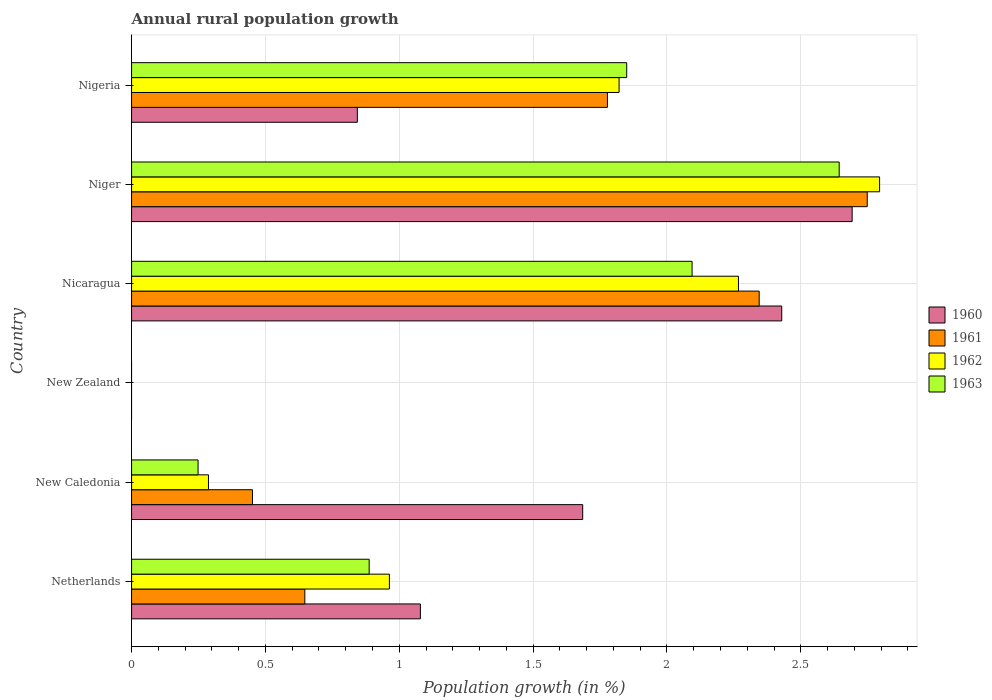How many different coloured bars are there?
Give a very brief answer. 4. What is the label of the 4th group of bars from the top?
Keep it short and to the point. New Zealand. What is the percentage of rural population growth in 1963 in Nigeria?
Ensure brevity in your answer.  1.85. Across all countries, what is the maximum percentage of rural population growth in 1963?
Your answer should be compact. 2.64. In which country was the percentage of rural population growth in 1961 maximum?
Offer a very short reply. Niger. What is the total percentage of rural population growth in 1961 in the graph?
Ensure brevity in your answer.  7.97. What is the difference between the percentage of rural population growth in 1962 in Nicaragua and that in Niger?
Offer a terse response. -0.53. What is the difference between the percentage of rural population growth in 1960 in Nigeria and the percentage of rural population growth in 1962 in Netherlands?
Your answer should be compact. -0.12. What is the average percentage of rural population growth in 1962 per country?
Provide a succinct answer. 1.36. What is the difference between the percentage of rural population growth in 1961 and percentage of rural population growth in 1962 in Nicaragua?
Your answer should be compact. 0.08. In how many countries, is the percentage of rural population growth in 1961 greater than 2.2 %?
Make the answer very short. 2. What is the ratio of the percentage of rural population growth in 1963 in New Caledonia to that in Nicaragua?
Keep it short and to the point. 0.12. Is the percentage of rural population growth in 1962 in Netherlands less than that in Nicaragua?
Make the answer very short. Yes. Is the difference between the percentage of rural population growth in 1961 in New Caledonia and Niger greater than the difference between the percentage of rural population growth in 1962 in New Caledonia and Niger?
Your response must be concise. Yes. What is the difference between the highest and the second highest percentage of rural population growth in 1963?
Make the answer very short. 0.55. What is the difference between the highest and the lowest percentage of rural population growth in 1960?
Provide a short and direct response. 2.69. Is it the case that in every country, the sum of the percentage of rural population growth in 1960 and percentage of rural population growth in 1962 is greater than the percentage of rural population growth in 1961?
Offer a terse response. No. Are all the bars in the graph horizontal?
Offer a very short reply. Yes. How many countries are there in the graph?
Make the answer very short. 6. Are the values on the major ticks of X-axis written in scientific E-notation?
Offer a very short reply. No. Where does the legend appear in the graph?
Ensure brevity in your answer.  Center right. What is the title of the graph?
Give a very brief answer. Annual rural population growth. What is the label or title of the X-axis?
Your answer should be very brief. Population growth (in %). What is the label or title of the Y-axis?
Your answer should be very brief. Country. What is the Population growth (in %) in 1960 in Netherlands?
Provide a succinct answer. 1.08. What is the Population growth (in %) in 1961 in Netherlands?
Keep it short and to the point. 0.65. What is the Population growth (in %) in 1962 in Netherlands?
Keep it short and to the point. 0.96. What is the Population growth (in %) in 1963 in Netherlands?
Your response must be concise. 0.89. What is the Population growth (in %) of 1960 in New Caledonia?
Your answer should be very brief. 1.69. What is the Population growth (in %) of 1961 in New Caledonia?
Your answer should be very brief. 0.45. What is the Population growth (in %) in 1962 in New Caledonia?
Your answer should be very brief. 0.29. What is the Population growth (in %) in 1963 in New Caledonia?
Ensure brevity in your answer.  0.25. What is the Population growth (in %) of 1960 in New Zealand?
Your response must be concise. 0. What is the Population growth (in %) of 1961 in New Zealand?
Ensure brevity in your answer.  0. What is the Population growth (in %) of 1960 in Nicaragua?
Offer a very short reply. 2.43. What is the Population growth (in %) of 1961 in Nicaragua?
Your answer should be compact. 2.34. What is the Population growth (in %) in 1962 in Nicaragua?
Give a very brief answer. 2.27. What is the Population growth (in %) of 1963 in Nicaragua?
Your response must be concise. 2.09. What is the Population growth (in %) in 1960 in Niger?
Your response must be concise. 2.69. What is the Population growth (in %) of 1961 in Niger?
Provide a succinct answer. 2.75. What is the Population growth (in %) in 1962 in Niger?
Provide a short and direct response. 2.79. What is the Population growth (in %) of 1963 in Niger?
Provide a short and direct response. 2.64. What is the Population growth (in %) in 1960 in Nigeria?
Provide a short and direct response. 0.84. What is the Population growth (in %) in 1961 in Nigeria?
Make the answer very short. 1.78. What is the Population growth (in %) of 1962 in Nigeria?
Give a very brief answer. 1.82. What is the Population growth (in %) of 1963 in Nigeria?
Provide a succinct answer. 1.85. Across all countries, what is the maximum Population growth (in %) in 1960?
Your response must be concise. 2.69. Across all countries, what is the maximum Population growth (in %) of 1961?
Your answer should be compact. 2.75. Across all countries, what is the maximum Population growth (in %) in 1962?
Offer a very short reply. 2.79. Across all countries, what is the maximum Population growth (in %) of 1963?
Provide a short and direct response. 2.64. Across all countries, what is the minimum Population growth (in %) in 1961?
Make the answer very short. 0. Across all countries, what is the minimum Population growth (in %) in 1962?
Keep it short and to the point. 0. What is the total Population growth (in %) in 1960 in the graph?
Your response must be concise. 8.73. What is the total Population growth (in %) of 1961 in the graph?
Offer a terse response. 7.97. What is the total Population growth (in %) in 1962 in the graph?
Provide a succinct answer. 8.13. What is the total Population growth (in %) in 1963 in the graph?
Make the answer very short. 7.72. What is the difference between the Population growth (in %) of 1960 in Netherlands and that in New Caledonia?
Your response must be concise. -0.61. What is the difference between the Population growth (in %) of 1961 in Netherlands and that in New Caledonia?
Your answer should be compact. 0.2. What is the difference between the Population growth (in %) of 1962 in Netherlands and that in New Caledonia?
Ensure brevity in your answer.  0.68. What is the difference between the Population growth (in %) in 1963 in Netherlands and that in New Caledonia?
Your answer should be very brief. 0.64. What is the difference between the Population growth (in %) in 1960 in Netherlands and that in Nicaragua?
Offer a very short reply. -1.35. What is the difference between the Population growth (in %) of 1961 in Netherlands and that in Nicaragua?
Provide a short and direct response. -1.7. What is the difference between the Population growth (in %) in 1962 in Netherlands and that in Nicaragua?
Make the answer very short. -1.3. What is the difference between the Population growth (in %) in 1963 in Netherlands and that in Nicaragua?
Provide a succinct answer. -1.21. What is the difference between the Population growth (in %) in 1960 in Netherlands and that in Niger?
Keep it short and to the point. -1.61. What is the difference between the Population growth (in %) in 1961 in Netherlands and that in Niger?
Offer a very short reply. -2.1. What is the difference between the Population growth (in %) of 1962 in Netherlands and that in Niger?
Your answer should be compact. -1.83. What is the difference between the Population growth (in %) in 1963 in Netherlands and that in Niger?
Offer a terse response. -1.76. What is the difference between the Population growth (in %) in 1960 in Netherlands and that in Nigeria?
Ensure brevity in your answer.  0.24. What is the difference between the Population growth (in %) of 1961 in Netherlands and that in Nigeria?
Your answer should be compact. -1.13. What is the difference between the Population growth (in %) of 1962 in Netherlands and that in Nigeria?
Your answer should be compact. -0.86. What is the difference between the Population growth (in %) in 1963 in Netherlands and that in Nigeria?
Offer a very short reply. -0.96. What is the difference between the Population growth (in %) of 1960 in New Caledonia and that in Nicaragua?
Give a very brief answer. -0.74. What is the difference between the Population growth (in %) of 1961 in New Caledonia and that in Nicaragua?
Provide a short and direct response. -1.89. What is the difference between the Population growth (in %) in 1962 in New Caledonia and that in Nicaragua?
Offer a terse response. -1.98. What is the difference between the Population growth (in %) in 1963 in New Caledonia and that in Nicaragua?
Ensure brevity in your answer.  -1.85. What is the difference between the Population growth (in %) in 1960 in New Caledonia and that in Niger?
Provide a succinct answer. -1.01. What is the difference between the Population growth (in %) in 1961 in New Caledonia and that in Niger?
Provide a succinct answer. -2.3. What is the difference between the Population growth (in %) of 1962 in New Caledonia and that in Niger?
Make the answer very short. -2.51. What is the difference between the Population growth (in %) of 1963 in New Caledonia and that in Niger?
Offer a very short reply. -2.4. What is the difference between the Population growth (in %) of 1960 in New Caledonia and that in Nigeria?
Offer a very short reply. 0.84. What is the difference between the Population growth (in %) in 1961 in New Caledonia and that in Nigeria?
Give a very brief answer. -1.33. What is the difference between the Population growth (in %) of 1962 in New Caledonia and that in Nigeria?
Keep it short and to the point. -1.53. What is the difference between the Population growth (in %) of 1963 in New Caledonia and that in Nigeria?
Provide a short and direct response. -1.6. What is the difference between the Population growth (in %) in 1960 in Nicaragua and that in Niger?
Your response must be concise. -0.26. What is the difference between the Population growth (in %) of 1961 in Nicaragua and that in Niger?
Provide a succinct answer. -0.4. What is the difference between the Population growth (in %) in 1962 in Nicaragua and that in Niger?
Make the answer very short. -0.53. What is the difference between the Population growth (in %) in 1963 in Nicaragua and that in Niger?
Provide a succinct answer. -0.55. What is the difference between the Population growth (in %) of 1960 in Nicaragua and that in Nigeria?
Give a very brief answer. 1.59. What is the difference between the Population growth (in %) in 1961 in Nicaragua and that in Nigeria?
Ensure brevity in your answer.  0.57. What is the difference between the Population growth (in %) in 1962 in Nicaragua and that in Nigeria?
Provide a short and direct response. 0.45. What is the difference between the Population growth (in %) of 1963 in Nicaragua and that in Nigeria?
Keep it short and to the point. 0.24. What is the difference between the Population growth (in %) in 1960 in Niger and that in Nigeria?
Provide a short and direct response. 1.85. What is the difference between the Population growth (in %) in 1961 in Niger and that in Nigeria?
Your answer should be very brief. 0.97. What is the difference between the Population growth (in %) in 1962 in Niger and that in Nigeria?
Your answer should be compact. 0.97. What is the difference between the Population growth (in %) in 1963 in Niger and that in Nigeria?
Provide a succinct answer. 0.79. What is the difference between the Population growth (in %) in 1960 in Netherlands and the Population growth (in %) in 1961 in New Caledonia?
Keep it short and to the point. 0.63. What is the difference between the Population growth (in %) in 1960 in Netherlands and the Population growth (in %) in 1962 in New Caledonia?
Offer a very short reply. 0.79. What is the difference between the Population growth (in %) in 1960 in Netherlands and the Population growth (in %) in 1963 in New Caledonia?
Your answer should be compact. 0.83. What is the difference between the Population growth (in %) of 1961 in Netherlands and the Population growth (in %) of 1962 in New Caledonia?
Make the answer very short. 0.36. What is the difference between the Population growth (in %) in 1961 in Netherlands and the Population growth (in %) in 1963 in New Caledonia?
Keep it short and to the point. 0.4. What is the difference between the Population growth (in %) in 1962 in Netherlands and the Population growth (in %) in 1963 in New Caledonia?
Provide a short and direct response. 0.71. What is the difference between the Population growth (in %) in 1960 in Netherlands and the Population growth (in %) in 1961 in Nicaragua?
Provide a short and direct response. -1.27. What is the difference between the Population growth (in %) in 1960 in Netherlands and the Population growth (in %) in 1962 in Nicaragua?
Ensure brevity in your answer.  -1.19. What is the difference between the Population growth (in %) in 1960 in Netherlands and the Population growth (in %) in 1963 in Nicaragua?
Offer a very short reply. -1.01. What is the difference between the Population growth (in %) of 1961 in Netherlands and the Population growth (in %) of 1962 in Nicaragua?
Make the answer very short. -1.62. What is the difference between the Population growth (in %) in 1961 in Netherlands and the Population growth (in %) in 1963 in Nicaragua?
Your response must be concise. -1.45. What is the difference between the Population growth (in %) of 1962 in Netherlands and the Population growth (in %) of 1963 in Nicaragua?
Provide a succinct answer. -1.13. What is the difference between the Population growth (in %) in 1960 in Netherlands and the Population growth (in %) in 1961 in Niger?
Offer a terse response. -1.67. What is the difference between the Population growth (in %) in 1960 in Netherlands and the Population growth (in %) in 1962 in Niger?
Make the answer very short. -1.72. What is the difference between the Population growth (in %) of 1960 in Netherlands and the Population growth (in %) of 1963 in Niger?
Your response must be concise. -1.56. What is the difference between the Population growth (in %) of 1961 in Netherlands and the Population growth (in %) of 1962 in Niger?
Your answer should be very brief. -2.15. What is the difference between the Population growth (in %) of 1961 in Netherlands and the Population growth (in %) of 1963 in Niger?
Your answer should be very brief. -2. What is the difference between the Population growth (in %) in 1962 in Netherlands and the Population growth (in %) in 1963 in Niger?
Your answer should be very brief. -1.68. What is the difference between the Population growth (in %) in 1960 in Netherlands and the Population growth (in %) in 1961 in Nigeria?
Your answer should be compact. -0.7. What is the difference between the Population growth (in %) in 1960 in Netherlands and the Population growth (in %) in 1962 in Nigeria?
Ensure brevity in your answer.  -0.74. What is the difference between the Population growth (in %) in 1960 in Netherlands and the Population growth (in %) in 1963 in Nigeria?
Offer a very short reply. -0.77. What is the difference between the Population growth (in %) in 1961 in Netherlands and the Population growth (in %) in 1962 in Nigeria?
Make the answer very short. -1.17. What is the difference between the Population growth (in %) of 1961 in Netherlands and the Population growth (in %) of 1963 in Nigeria?
Your response must be concise. -1.2. What is the difference between the Population growth (in %) of 1962 in Netherlands and the Population growth (in %) of 1963 in Nigeria?
Offer a terse response. -0.89. What is the difference between the Population growth (in %) in 1960 in New Caledonia and the Population growth (in %) in 1961 in Nicaragua?
Provide a succinct answer. -0.66. What is the difference between the Population growth (in %) in 1960 in New Caledonia and the Population growth (in %) in 1962 in Nicaragua?
Your answer should be compact. -0.58. What is the difference between the Population growth (in %) of 1960 in New Caledonia and the Population growth (in %) of 1963 in Nicaragua?
Offer a very short reply. -0.41. What is the difference between the Population growth (in %) in 1961 in New Caledonia and the Population growth (in %) in 1962 in Nicaragua?
Your response must be concise. -1.82. What is the difference between the Population growth (in %) in 1961 in New Caledonia and the Population growth (in %) in 1963 in Nicaragua?
Provide a succinct answer. -1.64. What is the difference between the Population growth (in %) of 1962 in New Caledonia and the Population growth (in %) of 1963 in Nicaragua?
Provide a succinct answer. -1.81. What is the difference between the Population growth (in %) in 1960 in New Caledonia and the Population growth (in %) in 1961 in Niger?
Offer a very short reply. -1.06. What is the difference between the Population growth (in %) of 1960 in New Caledonia and the Population growth (in %) of 1962 in Niger?
Your answer should be very brief. -1.11. What is the difference between the Population growth (in %) of 1960 in New Caledonia and the Population growth (in %) of 1963 in Niger?
Your response must be concise. -0.96. What is the difference between the Population growth (in %) in 1961 in New Caledonia and the Population growth (in %) in 1962 in Niger?
Offer a terse response. -2.34. What is the difference between the Population growth (in %) in 1961 in New Caledonia and the Population growth (in %) in 1963 in Niger?
Offer a very short reply. -2.19. What is the difference between the Population growth (in %) in 1962 in New Caledonia and the Population growth (in %) in 1963 in Niger?
Provide a succinct answer. -2.36. What is the difference between the Population growth (in %) in 1960 in New Caledonia and the Population growth (in %) in 1961 in Nigeria?
Make the answer very short. -0.09. What is the difference between the Population growth (in %) in 1960 in New Caledonia and the Population growth (in %) in 1962 in Nigeria?
Make the answer very short. -0.14. What is the difference between the Population growth (in %) in 1960 in New Caledonia and the Population growth (in %) in 1963 in Nigeria?
Give a very brief answer. -0.16. What is the difference between the Population growth (in %) in 1961 in New Caledonia and the Population growth (in %) in 1962 in Nigeria?
Give a very brief answer. -1.37. What is the difference between the Population growth (in %) in 1961 in New Caledonia and the Population growth (in %) in 1963 in Nigeria?
Give a very brief answer. -1.4. What is the difference between the Population growth (in %) in 1962 in New Caledonia and the Population growth (in %) in 1963 in Nigeria?
Your answer should be very brief. -1.56. What is the difference between the Population growth (in %) in 1960 in Nicaragua and the Population growth (in %) in 1961 in Niger?
Give a very brief answer. -0.32. What is the difference between the Population growth (in %) in 1960 in Nicaragua and the Population growth (in %) in 1962 in Niger?
Your answer should be very brief. -0.37. What is the difference between the Population growth (in %) in 1960 in Nicaragua and the Population growth (in %) in 1963 in Niger?
Give a very brief answer. -0.21. What is the difference between the Population growth (in %) of 1961 in Nicaragua and the Population growth (in %) of 1962 in Niger?
Provide a short and direct response. -0.45. What is the difference between the Population growth (in %) in 1961 in Nicaragua and the Population growth (in %) in 1963 in Niger?
Offer a terse response. -0.3. What is the difference between the Population growth (in %) in 1962 in Nicaragua and the Population growth (in %) in 1963 in Niger?
Provide a succinct answer. -0.38. What is the difference between the Population growth (in %) in 1960 in Nicaragua and the Population growth (in %) in 1961 in Nigeria?
Make the answer very short. 0.65. What is the difference between the Population growth (in %) of 1960 in Nicaragua and the Population growth (in %) of 1962 in Nigeria?
Your answer should be compact. 0.61. What is the difference between the Population growth (in %) of 1960 in Nicaragua and the Population growth (in %) of 1963 in Nigeria?
Offer a terse response. 0.58. What is the difference between the Population growth (in %) in 1961 in Nicaragua and the Population growth (in %) in 1962 in Nigeria?
Your response must be concise. 0.52. What is the difference between the Population growth (in %) in 1961 in Nicaragua and the Population growth (in %) in 1963 in Nigeria?
Make the answer very short. 0.49. What is the difference between the Population growth (in %) in 1962 in Nicaragua and the Population growth (in %) in 1963 in Nigeria?
Your answer should be very brief. 0.42. What is the difference between the Population growth (in %) of 1960 in Niger and the Population growth (in %) of 1961 in Nigeria?
Offer a terse response. 0.91. What is the difference between the Population growth (in %) of 1960 in Niger and the Population growth (in %) of 1962 in Nigeria?
Provide a succinct answer. 0.87. What is the difference between the Population growth (in %) of 1960 in Niger and the Population growth (in %) of 1963 in Nigeria?
Your response must be concise. 0.84. What is the difference between the Population growth (in %) in 1961 in Niger and the Population growth (in %) in 1962 in Nigeria?
Make the answer very short. 0.93. What is the difference between the Population growth (in %) of 1961 in Niger and the Population growth (in %) of 1963 in Nigeria?
Your answer should be very brief. 0.9. What is the difference between the Population growth (in %) of 1962 in Niger and the Population growth (in %) of 1963 in Nigeria?
Make the answer very short. 0.94. What is the average Population growth (in %) of 1960 per country?
Your answer should be compact. 1.45. What is the average Population growth (in %) in 1961 per country?
Give a very brief answer. 1.33. What is the average Population growth (in %) in 1962 per country?
Your response must be concise. 1.36. What is the average Population growth (in %) in 1963 per country?
Your answer should be very brief. 1.29. What is the difference between the Population growth (in %) of 1960 and Population growth (in %) of 1961 in Netherlands?
Your answer should be very brief. 0.43. What is the difference between the Population growth (in %) of 1960 and Population growth (in %) of 1962 in Netherlands?
Make the answer very short. 0.12. What is the difference between the Population growth (in %) of 1960 and Population growth (in %) of 1963 in Netherlands?
Give a very brief answer. 0.19. What is the difference between the Population growth (in %) of 1961 and Population growth (in %) of 1962 in Netherlands?
Your response must be concise. -0.32. What is the difference between the Population growth (in %) in 1961 and Population growth (in %) in 1963 in Netherlands?
Provide a succinct answer. -0.24. What is the difference between the Population growth (in %) in 1962 and Population growth (in %) in 1963 in Netherlands?
Provide a succinct answer. 0.08. What is the difference between the Population growth (in %) in 1960 and Population growth (in %) in 1961 in New Caledonia?
Give a very brief answer. 1.23. What is the difference between the Population growth (in %) in 1960 and Population growth (in %) in 1962 in New Caledonia?
Your answer should be compact. 1.4. What is the difference between the Population growth (in %) in 1960 and Population growth (in %) in 1963 in New Caledonia?
Offer a terse response. 1.44. What is the difference between the Population growth (in %) of 1961 and Population growth (in %) of 1962 in New Caledonia?
Ensure brevity in your answer.  0.16. What is the difference between the Population growth (in %) of 1961 and Population growth (in %) of 1963 in New Caledonia?
Your answer should be compact. 0.2. What is the difference between the Population growth (in %) in 1962 and Population growth (in %) in 1963 in New Caledonia?
Your answer should be very brief. 0.04. What is the difference between the Population growth (in %) in 1960 and Population growth (in %) in 1961 in Nicaragua?
Provide a short and direct response. 0.08. What is the difference between the Population growth (in %) of 1960 and Population growth (in %) of 1962 in Nicaragua?
Your response must be concise. 0.16. What is the difference between the Population growth (in %) in 1960 and Population growth (in %) in 1963 in Nicaragua?
Ensure brevity in your answer.  0.33. What is the difference between the Population growth (in %) of 1961 and Population growth (in %) of 1962 in Nicaragua?
Offer a terse response. 0.08. What is the difference between the Population growth (in %) in 1961 and Population growth (in %) in 1963 in Nicaragua?
Ensure brevity in your answer.  0.25. What is the difference between the Population growth (in %) of 1962 and Population growth (in %) of 1963 in Nicaragua?
Give a very brief answer. 0.17. What is the difference between the Population growth (in %) of 1960 and Population growth (in %) of 1961 in Niger?
Make the answer very short. -0.06. What is the difference between the Population growth (in %) of 1960 and Population growth (in %) of 1962 in Niger?
Your answer should be compact. -0.1. What is the difference between the Population growth (in %) in 1960 and Population growth (in %) in 1963 in Niger?
Your answer should be very brief. 0.05. What is the difference between the Population growth (in %) of 1961 and Population growth (in %) of 1962 in Niger?
Offer a terse response. -0.05. What is the difference between the Population growth (in %) in 1961 and Population growth (in %) in 1963 in Niger?
Your answer should be very brief. 0.1. What is the difference between the Population growth (in %) of 1962 and Population growth (in %) of 1963 in Niger?
Provide a succinct answer. 0.15. What is the difference between the Population growth (in %) of 1960 and Population growth (in %) of 1961 in Nigeria?
Offer a terse response. -0.93. What is the difference between the Population growth (in %) in 1960 and Population growth (in %) in 1962 in Nigeria?
Your answer should be very brief. -0.98. What is the difference between the Population growth (in %) in 1960 and Population growth (in %) in 1963 in Nigeria?
Offer a terse response. -1.01. What is the difference between the Population growth (in %) in 1961 and Population growth (in %) in 1962 in Nigeria?
Provide a succinct answer. -0.04. What is the difference between the Population growth (in %) of 1961 and Population growth (in %) of 1963 in Nigeria?
Your answer should be compact. -0.07. What is the difference between the Population growth (in %) in 1962 and Population growth (in %) in 1963 in Nigeria?
Give a very brief answer. -0.03. What is the ratio of the Population growth (in %) in 1960 in Netherlands to that in New Caledonia?
Ensure brevity in your answer.  0.64. What is the ratio of the Population growth (in %) of 1961 in Netherlands to that in New Caledonia?
Give a very brief answer. 1.43. What is the ratio of the Population growth (in %) of 1962 in Netherlands to that in New Caledonia?
Your response must be concise. 3.35. What is the ratio of the Population growth (in %) in 1963 in Netherlands to that in New Caledonia?
Keep it short and to the point. 3.57. What is the ratio of the Population growth (in %) of 1960 in Netherlands to that in Nicaragua?
Give a very brief answer. 0.44. What is the ratio of the Population growth (in %) of 1961 in Netherlands to that in Nicaragua?
Provide a short and direct response. 0.28. What is the ratio of the Population growth (in %) of 1962 in Netherlands to that in Nicaragua?
Offer a very short reply. 0.42. What is the ratio of the Population growth (in %) of 1963 in Netherlands to that in Nicaragua?
Provide a succinct answer. 0.42. What is the ratio of the Population growth (in %) in 1960 in Netherlands to that in Niger?
Your answer should be very brief. 0.4. What is the ratio of the Population growth (in %) in 1961 in Netherlands to that in Niger?
Your response must be concise. 0.24. What is the ratio of the Population growth (in %) of 1962 in Netherlands to that in Niger?
Give a very brief answer. 0.34. What is the ratio of the Population growth (in %) in 1963 in Netherlands to that in Niger?
Provide a short and direct response. 0.34. What is the ratio of the Population growth (in %) of 1960 in Netherlands to that in Nigeria?
Offer a very short reply. 1.28. What is the ratio of the Population growth (in %) in 1961 in Netherlands to that in Nigeria?
Make the answer very short. 0.36. What is the ratio of the Population growth (in %) in 1962 in Netherlands to that in Nigeria?
Ensure brevity in your answer.  0.53. What is the ratio of the Population growth (in %) of 1963 in Netherlands to that in Nigeria?
Your response must be concise. 0.48. What is the ratio of the Population growth (in %) in 1960 in New Caledonia to that in Nicaragua?
Keep it short and to the point. 0.69. What is the ratio of the Population growth (in %) of 1961 in New Caledonia to that in Nicaragua?
Make the answer very short. 0.19. What is the ratio of the Population growth (in %) of 1962 in New Caledonia to that in Nicaragua?
Keep it short and to the point. 0.13. What is the ratio of the Population growth (in %) in 1963 in New Caledonia to that in Nicaragua?
Ensure brevity in your answer.  0.12. What is the ratio of the Population growth (in %) of 1960 in New Caledonia to that in Niger?
Your response must be concise. 0.63. What is the ratio of the Population growth (in %) in 1961 in New Caledonia to that in Niger?
Your response must be concise. 0.16. What is the ratio of the Population growth (in %) of 1962 in New Caledonia to that in Niger?
Ensure brevity in your answer.  0.1. What is the ratio of the Population growth (in %) in 1963 in New Caledonia to that in Niger?
Your response must be concise. 0.09. What is the ratio of the Population growth (in %) in 1960 in New Caledonia to that in Nigeria?
Make the answer very short. 2. What is the ratio of the Population growth (in %) of 1961 in New Caledonia to that in Nigeria?
Ensure brevity in your answer.  0.25. What is the ratio of the Population growth (in %) in 1962 in New Caledonia to that in Nigeria?
Make the answer very short. 0.16. What is the ratio of the Population growth (in %) of 1963 in New Caledonia to that in Nigeria?
Give a very brief answer. 0.13. What is the ratio of the Population growth (in %) of 1960 in Nicaragua to that in Niger?
Your answer should be very brief. 0.9. What is the ratio of the Population growth (in %) in 1961 in Nicaragua to that in Niger?
Give a very brief answer. 0.85. What is the ratio of the Population growth (in %) in 1962 in Nicaragua to that in Niger?
Make the answer very short. 0.81. What is the ratio of the Population growth (in %) of 1963 in Nicaragua to that in Niger?
Offer a terse response. 0.79. What is the ratio of the Population growth (in %) of 1960 in Nicaragua to that in Nigeria?
Keep it short and to the point. 2.88. What is the ratio of the Population growth (in %) of 1961 in Nicaragua to that in Nigeria?
Your answer should be very brief. 1.32. What is the ratio of the Population growth (in %) in 1962 in Nicaragua to that in Nigeria?
Your response must be concise. 1.24. What is the ratio of the Population growth (in %) in 1963 in Nicaragua to that in Nigeria?
Offer a very short reply. 1.13. What is the ratio of the Population growth (in %) of 1960 in Niger to that in Nigeria?
Your answer should be compact. 3.19. What is the ratio of the Population growth (in %) in 1961 in Niger to that in Nigeria?
Make the answer very short. 1.55. What is the ratio of the Population growth (in %) of 1962 in Niger to that in Nigeria?
Give a very brief answer. 1.53. What is the ratio of the Population growth (in %) in 1963 in Niger to that in Nigeria?
Keep it short and to the point. 1.43. What is the difference between the highest and the second highest Population growth (in %) in 1960?
Provide a short and direct response. 0.26. What is the difference between the highest and the second highest Population growth (in %) of 1961?
Ensure brevity in your answer.  0.4. What is the difference between the highest and the second highest Population growth (in %) in 1962?
Keep it short and to the point. 0.53. What is the difference between the highest and the second highest Population growth (in %) of 1963?
Your response must be concise. 0.55. What is the difference between the highest and the lowest Population growth (in %) of 1960?
Your answer should be very brief. 2.69. What is the difference between the highest and the lowest Population growth (in %) of 1961?
Offer a terse response. 2.75. What is the difference between the highest and the lowest Population growth (in %) in 1962?
Give a very brief answer. 2.79. What is the difference between the highest and the lowest Population growth (in %) of 1963?
Provide a short and direct response. 2.64. 